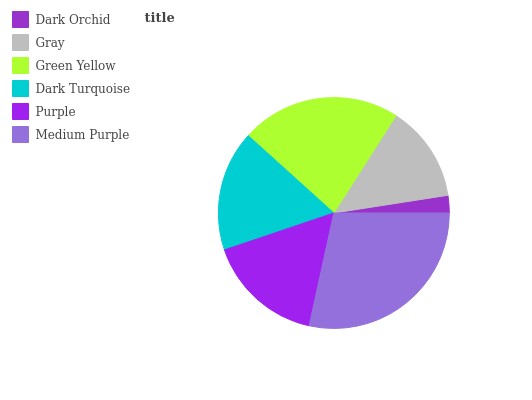Is Dark Orchid the minimum?
Answer yes or no. Yes. Is Medium Purple the maximum?
Answer yes or no. Yes. Is Gray the minimum?
Answer yes or no. No. Is Gray the maximum?
Answer yes or no. No. Is Gray greater than Dark Orchid?
Answer yes or no. Yes. Is Dark Orchid less than Gray?
Answer yes or no. Yes. Is Dark Orchid greater than Gray?
Answer yes or no. No. Is Gray less than Dark Orchid?
Answer yes or no. No. Is Dark Turquoise the high median?
Answer yes or no. Yes. Is Purple the low median?
Answer yes or no. Yes. Is Purple the high median?
Answer yes or no. No. Is Green Yellow the low median?
Answer yes or no. No. 